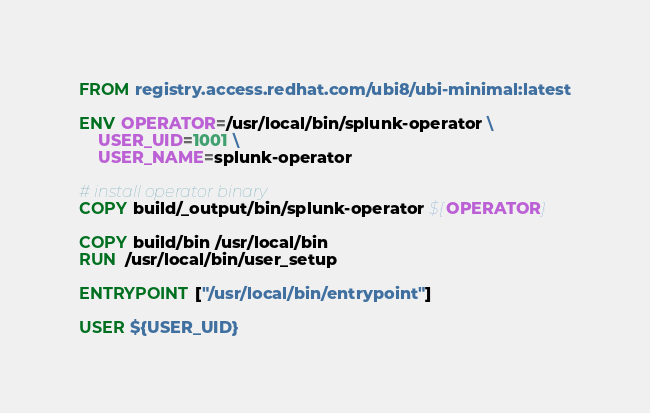<code> <loc_0><loc_0><loc_500><loc_500><_Dockerfile_>FROM registry.access.redhat.com/ubi8/ubi-minimal:latest

ENV OPERATOR=/usr/local/bin/splunk-operator \
    USER_UID=1001 \
    USER_NAME=splunk-operator

# install operator binary
COPY build/_output/bin/splunk-operator ${OPERATOR}

COPY build/bin /usr/local/bin
RUN  /usr/local/bin/user_setup

ENTRYPOINT ["/usr/local/bin/entrypoint"]

USER ${USER_UID}
</code> 